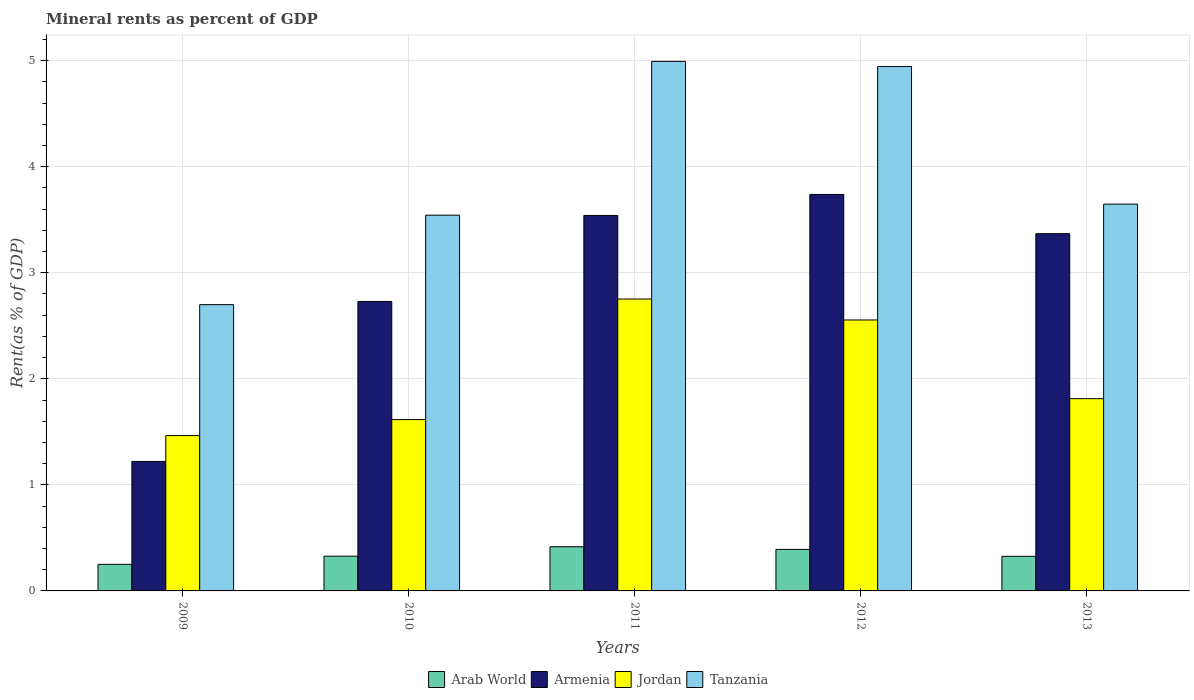How many different coloured bars are there?
Ensure brevity in your answer.  4. How many groups of bars are there?
Your answer should be very brief. 5. Are the number of bars per tick equal to the number of legend labels?
Make the answer very short. Yes. How many bars are there on the 5th tick from the right?
Your answer should be compact. 4. In how many cases, is the number of bars for a given year not equal to the number of legend labels?
Your answer should be very brief. 0. What is the mineral rent in Armenia in 2009?
Provide a short and direct response. 1.22. Across all years, what is the maximum mineral rent in Jordan?
Provide a short and direct response. 2.75. Across all years, what is the minimum mineral rent in Arab World?
Your answer should be very brief. 0.25. In which year was the mineral rent in Tanzania maximum?
Your answer should be very brief. 2011. In which year was the mineral rent in Jordan minimum?
Provide a short and direct response. 2009. What is the total mineral rent in Armenia in the graph?
Ensure brevity in your answer.  14.6. What is the difference between the mineral rent in Arab World in 2011 and that in 2012?
Offer a terse response. 0.03. What is the difference between the mineral rent in Armenia in 2010 and the mineral rent in Jordan in 2013?
Offer a terse response. 0.92. What is the average mineral rent in Jordan per year?
Ensure brevity in your answer.  2.04. In the year 2010, what is the difference between the mineral rent in Jordan and mineral rent in Arab World?
Keep it short and to the point. 1.29. What is the ratio of the mineral rent in Tanzania in 2009 to that in 2013?
Provide a short and direct response. 0.74. Is the mineral rent in Jordan in 2009 less than that in 2010?
Make the answer very short. Yes. What is the difference between the highest and the second highest mineral rent in Armenia?
Ensure brevity in your answer.  0.2. What is the difference between the highest and the lowest mineral rent in Armenia?
Offer a terse response. 2.52. Is the sum of the mineral rent in Jordan in 2012 and 2013 greater than the maximum mineral rent in Armenia across all years?
Provide a short and direct response. Yes. Is it the case that in every year, the sum of the mineral rent in Arab World and mineral rent in Armenia is greater than the sum of mineral rent in Jordan and mineral rent in Tanzania?
Offer a terse response. Yes. What does the 4th bar from the left in 2013 represents?
Your answer should be very brief. Tanzania. What does the 1st bar from the right in 2009 represents?
Ensure brevity in your answer.  Tanzania. Are all the bars in the graph horizontal?
Offer a very short reply. No. Are the values on the major ticks of Y-axis written in scientific E-notation?
Give a very brief answer. No. Does the graph contain any zero values?
Your answer should be compact. No. Where does the legend appear in the graph?
Provide a succinct answer. Bottom center. How many legend labels are there?
Give a very brief answer. 4. How are the legend labels stacked?
Your response must be concise. Horizontal. What is the title of the graph?
Offer a very short reply. Mineral rents as percent of GDP. Does "Chad" appear as one of the legend labels in the graph?
Give a very brief answer. No. What is the label or title of the Y-axis?
Make the answer very short. Rent(as % of GDP). What is the Rent(as % of GDP) of Arab World in 2009?
Ensure brevity in your answer.  0.25. What is the Rent(as % of GDP) of Armenia in 2009?
Provide a short and direct response. 1.22. What is the Rent(as % of GDP) in Jordan in 2009?
Provide a succinct answer. 1.46. What is the Rent(as % of GDP) in Tanzania in 2009?
Make the answer very short. 2.7. What is the Rent(as % of GDP) in Arab World in 2010?
Your answer should be compact. 0.33. What is the Rent(as % of GDP) in Armenia in 2010?
Offer a terse response. 2.73. What is the Rent(as % of GDP) of Jordan in 2010?
Ensure brevity in your answer.  1.62. What is the Rent(as % of GDP) in Tanzania in 2010?
Make the answer very short. 3.54. What is the Rent(as % of GDP) in Arab World in 2011?
Your response must be concise. 0.42. What is the Rent(as % of GDP) of Armenia in 2011?
Make the answer very short. 3.54. What is the Rent(as % of GDP) in Jordan in 2011?
Offer a very short reply. 2.75. What is the Rent(as % of GDP) of Tanzania in 2011?
Provide a succinct answer. 4.99. What is the Rent(as % of GDP) in Arab World in 2012?
Your answer should be very brief. 0.39. What is the Rent(as % of GDP) of Armenia in 2012?
Give a very brief answer. 3.74. What is the Rent(as % of GDP) in Jordan in 2012?
Offer a terse response. 2.55. What is the Rent(as % of GDP) of Tanzania in 2012?
Offer a terse response. 4.94. What is the Rent(as % of GDP) in Arab World in 2013?
Provide a short and direct response. 0.33. What is the Rent(as % of GDP) in Armenia in 2013?
Your response must be concise. 3.37. What is the Rent(as % of GDP) of Jordan in 2013?
Make the answer very short. 1.81. What is the Rent(as % of GDP) in Tanzania in 2013?
Your answer should be very brief. 3.65. Across all years, what is the maximum Rent(as % of GDP) in Arab World?
Offer a terse response. 0.42. Across all years, what is the maximum Rent(as % of GDP) in Armenia?
Provide a succinct answer. 3.74. Across all years, what is the maximum Rent(as % of GDP) in Jordan?
Offer a very short reply. 2.75. Across all years, what is the maximum Rent(as % of GDP) in Tanzania?
Provide a succinct answer. 4.99. Across all years, what is the minimum Rent(as % of GDP) in Arab World?
Keep it short and to the point. 0.25. Across all years, what is the minimum Rent(as % of GDP) in Armenia?
Ensure brevity in your answer.  1.22. Across all years, what is the minimum Rent(as % of GDP) of Jordan?
Offer a very short reply. 1.46. Across all years, what is the minimum Rent(as % of GDP) in Tanzania?
Ensure brevity in your answer.  2.7. What is the total Rent(as % of GDP) of Arab World in the graph?
Offer a terse response. 1.71. What is the total Rent(as % of GDP) of Armenia in the graph?
Offer a terse response. 14.6. What is the total Rent(as % of GDP) in Jordan in the graph?
Offer a very short reply. 10.2. What is the total Rent(as % of GDP) of Tanzania in the graph?
Provide a short and direct response. 19.83. What is the difference between the Rent(as % of GDP) in Arab World in 2009 and that in 2010?
Provide a succinct answer. -0.08. What is the difference between the Rent(as % of GDP) in Armenia in 2009 and that in 2010?
Your answer should be compact. -1.51. What is the difference between the Rent(as % of GDP) in Jordan in 2009 and that in 2010?
Ensure brevity in your answer.  -0.15. What is the difference between the Rent(as % of GDP) of Tanzania in 2009 and that in 2010?
Your response must be concise. -0.84. What is the difference between the Rent(as % of GDP) in Arab World in 2009 and that in 2011?
Keep it short and to the point. -0.17. What is the difference between the Rent(as % of GDP) in Armenia in 2009 and that in 2011?
Provide a short and direct response. -2.32. What is the difference between the Rent(as % of GDP) in Jordan in 2009 and that in 2011?
Offer a very short reply. -1.29. What is the difference between the Rent(as % of GDP) in Tanzania in 2009 and that in 2011?
Provide a succinct answer. -2.29. What is the difference between the Rent(as % of GDP) in Arab World in 2009 and that in 2012?
Give a very brief answer. -0.14. What is the difference between the Rent(as % of GDP) in Armenia in 2009 and that in 2012?
Your answer should be very brief. -2.52. What is the difference between the Rent(as % of GDP) of Jordan in 2009 and that in 2012?
Give a very brief answer. -1.09. What is the difference between the Rent(as % of GDP) of Tanzania in 2009 and that in 2012?
Give a very brief answer. -2.25. What is the difference between the Rent(as % of GDP) of Arab World in 2009 and that in 2013?
Provide a succinct answer. -0.08. What is the difference between the Rent(as % of GDP) in Armenia in 2009 and that in 2013?
Offer a terse response. -2.15. What is the difference between the Rent(as % of GDP) of Jordan in 2009 and that in 2013?
Ensure brevity in your answer.  -0.35. What is the difference between the Rent(as % of GDP) in Tanzania in 2009 and that in 2013?
Give a very brief answer. -0.95. What is the difference between the Rent(as % of GDP) in Arab World in 2010 and that in 2011?
Your answer should be very brief. -0.09. What is the difference between the Rent(as % of GDP) of Armenia in 2010 and that in 2011?
Your answer should be compact. -0.81. What is the difference between the Rent(as % of GDP) in Jordan in 2010 and that in 2011?
Give a very brief answer. -1.14. What is the difference between the Rent(as % of GDP) in Tanzania in 2010 and that in 2011?
Your response must be concise. -1.45. What is the difference between the Rent(as % of GDP) of Arab World in 2010 and that in 2012?
Provide a short and direct response. -0.06. What is the difference between the Rent(as % of GDP) in Armenia in 2010 and that in 2012?
Offer a very short reply. -1.01. What is the difference between the Rent(as % of GDP) of Jordan in 2010 and that in 2012?
Offer a terse response. -0.94. What is the difference between the Rent(as % of GDP) in Tanzania in 2010 and that in 2012?
Your answer should be very brief. -1.4. What is the difference between the Rent(as % of GDP) of Arab World in 2010 and that in 2013?
Make the answer very short. 0. What is the difference between the Rent(as % of GDP) in Armenia in 2010 and that in 2013?
Ensure brevity in your answer.  -0.64. What is the difference between the Rent(as % of GDP) of Jordan in 2010 and that in 2013?
Your response must be concise. -0.2. What is the difference between the Rent(as % of GDP) in Tanzania in 2010 and that in 2013?
Your answer should be very brief. -0.1. What is the difference between the Rent(as % of GDP) of Arab World in 2011 and that in 2012?
Offer a very short reply. 0.03. What is the difference between the Rent(as % of GDP) of Armenia in 2011 and that in 2012?
Keep it short and to the point. -0.2. What is the difference between the Rent(as % of GDP) of Jordan in 2011 and that in 2012?
Give a very brief answer. 0.2. What is the difference between the Rent(as % of GDP) in Tanzania in 2011 and that in 2012?
Make the answer very short. 0.05. What is the difference between the Rent(as % of GDP) in Arab World in 2011 and that in 2013?
Your answer should be very brief. 0.09. What is the difference between the Rent(as % of GDP) of Armenia in 2011 and that in 2013?
Keep it short and to the point. 0.17. What is the difference between the Rent(as % of GDP) of Jordan in 2011 and that in 2013?
Provide a succinct answer. 0.94. What is the difference between the Rent(as % of GDP) in Tanzania in 2011 and that in 2013?
Your answer should be compact. 1.35. What is the difference between the Rent(as % of GDP) of Arab World in 2012 and that in 2013?
Offer a very short reply. 0.07. What is the difference between the Rent(as % of GDP) of Armenia in 2012 and that in 2013?
Ensure brevity in your answer.  0.37. What is the difference between the Rent(as % of GDP) of Jordan in 2012 and that in 2013?
Offer a terse response. 0.74. What is the difference between the Rent(as % of GDP) in Tanzania in 2012 and that in 2013?
Offer a terse response. 1.3. What is the difference between the Rent(as % of GDP) of Arab World in 2009 and the Rent(as % of GDP) of Armenia in 2010?
Provide a short and direct response. -2.48. What is the difference between the Rent(as % of GDP) of Arab World in 2009 and the Rent(as % of GDP) of Jordan in 2010?
Provide a short and direct response. -1.36. What is the difference between the Rent(as % of GDP) of Arab World in 2009 and the Rent(as % of GDP) of Tanzania in 2010?
Offer a very short reply. -3.29. What is the difference between the Rent(as % of GDP) in Armenia in 2009 and the Rent(as % of GDP) in Jordan in 2010?
Give a very brief answer. -0.39. What is the difference between the Rent(as % of GDP) of Armenia in 2009 and the Rent(as % of GDP) of Tanzania in 2010?
Your answer should be compact. -2.32. What is the difference between the Rent(as % of GDP) of Jordan in 2009 and the Rent(as % of GDP) of Tanzania in 2010?
Offer a terse response. -2.08. What is the difference between the Rent(as % of GDP) of Arab World in 2009 and the Rent(as % of GDP) of Armenia in 2011?
Provide a succinct answer. -3.29. What is the difference between the Rent(as % of GDP) of Arab World in 2009 and the Rent(as % of GDP) of Jordan in 2011?
Your answer should be very brief. -2.5. What is the difference between the Rent(as % of GDP) of Arab World in 2009 and the Rent(as % of GDP) of Tanzania in 2011?
Provide a short and direct response. -4.74. What is the difference between the Rent(as % of GDP) in Armenia in 2009 and the Rent(as % of GDP) in Jordan in 2011?
Give a very brief answer. -1.53. What is the difference between the Rent(as % of GDP) in Armenia in 2009 and the Rent(as % of GDP) in Tanzania in 2011?
Offer a very short reply. -3.77. What is the difference between the Rent(as % of GDP) of Jordan in 2009 and the Rent(as % of GDP) of Tanzania in 2011?
Ensure brevity in your answer.  -3.53. What is the difference between the Rent(as % of GDP) of Arab World in 2009 and the Rent(as % of GDP) of Armenia in 2012?
Give a very brief answer. -3.49. What is the difference between the Rent(as % of GDP) in Arab World in 2009 and the Rent(as % of GDP) in Jordan in 2012?
Offer a terse response. -2.3. What is the difference between the Rent(as % of GDP) in Arab World in 2009 and the Rent(as % of GDP) in Tanzania in 2012?
Provide a short and direct response. -4.69. What is the difference between the Rent(as % of GDP) in Armenia in 2009 and the Rent(as % of GDP) in Jordan in 2012?
Keep it short and to the point. -1.33. What is the difference between the Rent(as % of GDP) of Armenia in 2009 and the Rent(as % of GDP) of Tanzania in 2012?
Offer a terse response. -3.72. What is the difference between the Rent(as % of GDP) of Jordan in 2009 and the Rent(as % of GDP) of Tanzania in 2012?
Your response must be concise. -3.48. What is the difference between the Rent(as % of GDP) of Arab World in 2009 and the Rent(as % of GDP) of Armenia in 2013?
Keep it short and to the point. -3.12. What is the difference between the Rent(as % of GDP) in Arab World in 2009 and the Rent(as % of GDP) in Jordan in 2013?
Give a very brief answer. -1.56. What is the difference between the Rent(as % of GDP) of Arab World in 2009 and the Rent(as % of GDP) of Tanzania in 2013?
Your answer should be very brief. -3.4. What is the difference between the Rent(as % of GDP) of Armenia in 2009 and the Rent(as % of GDP) of Jordan in 2013?
Give a very brief answer. -0.59. What is the difference between the Rent(as % of GDP) of Armenia in 2009 and the Rent(as % of GDP) of Tanzania in 2013?
Ensure brevity in your answer.  -2.43. What is the difference between the Rent(as % of GDP) in Jordan in 2009 and the Rent(as % of GDP) in Tanzania in 2013?
Provide a short and direct response. -2.18. What is the difference between the Rent(as % of GDP) of Arab World in 2010 and the Rent(as % of GDP) of Armenia in 2011?
Make the answer very short. -3.21. What is the difference between the Rent(as % of GDP) in Arab World in 2010 and the Rent(as % of GDP) in Jordan in 2011?
Give a very brief answer. -2.42. What is the difference between the Rent(as % of GDP) in Arab World in 2010 and the Rent(as % of GDP) in Tanzania in 2011?
Your answer should be very brief. -4.67. What is the difference between the Rent(as % of GDP) in Armenia in 2010 and the Rent(as % of GDP) in Jordan in 2011?
Offer a very short reply. -0.02. What is the difference between the Rent(as % of GDP) in Armenia in 2010 and the Rent(as % of GDP) in Tanzania in 2011?
Your answer should be compact. -2.26. What is the difference between the Rent(as % of GDP) in Jordan in 2010 and the Rent(as % of GDP) in Tanzania in 2011?
Provide a succinct answer. -3.38. What is the difference between the Rent(as % of GDP) in Arab World in 2010 and the Rent(as % of GDP) in Armenia in 2012?
Provide a succinct answer. -3.41. What is the difference between the Rent(as % of GDP) of Arab World in 2010 and the Rent(as % of GDP) of Jordan in 2012?
Offer a terse response. -2.23. What is the difference between the Rent(as % of GDP) of Arab World in 2010 and the Rent(as % of GDP) of Tanzania in 2012?
Provide a succinct answer. -4.62. What is the difference between the Rent(as % of GDP) of Armenia in 2010 and the Rent(as % of GDP) of Jordan in 2012?
Your answer should be very brief. 0.17. What is the difference between the Rent(as % of GDP) in Armenia in 2010 and the Rent(as % of GDP) in Tanzania in 2012?
Offer a terse response. -2.21. What is the difference between the Rent(as % of GDP) in Jordan in 2010 and the Rent(as % of GDP) in Tanzania in 2012?
Give a very brief answer. -3.33. What is the difference between the Rent(as % of GDP) in Arab World in 2010 and the Rent(as % of GDP) in Armenia in 2013?
Provide a succinct answer. -3.04. What is the difference between the Rent(as % of GDP) of Arab World in 2010 and the Rent(as % of GDP) of Jordan in 2013?
Offer a terse response. -1.49. What is the difference between the Rent(as % of GDP) of Arab World in 2010 and the Rent(as % of GDP) of Tanzania in 2013?
Make the answer very short. -3.32. What is the difference between the Rent(as % of GDP) of Armenia in 2010 and the Rent(as % of GDP) of Jordan in 2013?
Offer a terse response. 0.92. What is the difference between the Rent(as % of GDP) of Armenia in 2010 and the Rent(as % of GDP) of Tanzania in 2013?
Keep it short and to the point. -0.92. What is the difference between the Rent(as % of GDP) in Jordan in 2010 and the Rent(as % of GDP) in Tanzania in 2013?
Ensure brevity in your answer.  -2.03. What is the difference between the Rent(as % of GDP) in Arab World in 2011 and the Rent(as % of GDP) in Armenia in 2012?
Provide a short and direct response. -3.32. What is the difference between the Rent(as % of GDP) in Arab World in 2011 and the Rent(as % of GDP) in Jordan in 2012?
Offer a terse response. -2.14. What is the difference between the Rent(as % of GDP) in Arab World in 2011 and the Rent(as % of GDP) in Tanzania in 2012?
Give a very brief answer. -4.53. What is the difference between the Rent(as % of GDP) of Armenia in 2011 and the Rent(as % of GDP) of Jordan in 2012?
Your answer should be compact. 0.99. What is the difference between the Rent(as % of GDP) in Armenia in 2011 and the Rent(as % of GDP) in Tanzania in 2012?
Keep it short and to the point. -1.4. What is the difference between the Rent(as % of GDP) of Jordan in 2011 and the Rent(as % of GDP) of Tanzania in 2012?
Offer a very short reply. -2.19. What is the difference between the Rent(as % of GDP) in Arab World in 2011 and the Rent(as % of GDP) in Armenia in 2013?
Provide a succinct answer. -2.95. What is the difference between the Rent(as % of GDP) in Arab World in 2011 and the Rent(as % of GDP) in Jordan in 2013?
Give a very brief answer. -1.4. What is the difference between the Rent(as % of GDP) of Arab World in 2011 and the Rent(as % of GDP) of Tanzania in 2013?
Provide a succinct answer. -3.23. What is the difference between the Rent(as % of GDP) in Armenia in 2011 and the Rent(as % of GDP) in Jordan in 2013?
Make the answer very short. 1.73. What is the difference between the Rent(as % of GDP) in Armenia in 2011 and the Rent(as % of GDP) in Tanzania in 2013?
Offer a very short reply. -0.11. What is the difference between the Rent(as % of GDP) in Jordan in 2011 and the Rent(as % of GDP) in Tanzania in 2013?
Provide a short and direct response. -0.89. What is the difference between the Rent(as % of GDP) in Arab World in 2012 and the Rent(as % of GDP) in Armenia in 2013?
Your response must be concise. -2.98. What is the difference between the Rent(as % of GDP) in Arab World in 2012 and the Rent(as % of GDP) in Jordan in 2013?
Offer a very short reply. -1.42. What is the difference between the Rent(as % of GDP) of Arab World in 2012 and the Rent(as % of GDP) of Tanzania in 2013?
Give a very brief answer. -3.26. What is the difference between the Rent(as % of GDP) in Armenia in 2012 and the Rent(as % of GDP) in Jordan in 2013?
Keep it short and to the point. 1.93. What is the difference between the Rent(as % of GDP) of Armenia in 2012 and the Rent(as % of GDP) of Tanzania in 2013?
Ensure brevity in your answer.  0.09. What is the difference between the Rent(as % of GDP) of Jordan in 2012 and the Rent(as % of GDP) of Tanzania in 2013?
Your answer should be very brief. -1.09. What is the average Rent(as % of GDP) of Arab World per year?
Provide a succinct answer. 0.34. What is the average Rent(as % of GDP) in Armenia per year?
Your answer should be very brief. 2.92. What is the average Rent(as % of GDP) in Jordan per year?
Offer a very short reply. 2.04. What is the average Rent(as % of GDP) of Tanzania per year?
Your response must be concise. 3.97. In the year 2009, what is the difference between the Rent(as % of GDP) of Arab World and Rent(as % of GDP) of Armenia?
Offer a very short reply. -0.97. In the year 2009, what is the difference between the Rent(as % of GDP) of Arab World and Rent(as % of GDP) of Jordan?
Provide a short and direct response. -1.21. In the year 2009, what is the difference between the Rent(as % of GDP) in Arab World and Rent(as % of GDP) in Tanzania?
Keep it short and to the point. -2.45. In the year 2009, what is the difference between the Rent(as % of GDP) in Armenia and Rent(as % of GDP) in Jordan?
Provide a succinct answer. -0.24. In the year 2009, what is the difference between the Rent(as % of GDP) in Armenia and Rent(as % of GDP) in Tanzania?
Offer a terse response. -1.48. In the year 2009, what is the difference between the Rent(as % of GDP) in Jordan and Rent(as % of GDP) in Tanzania?
Make the answer very short. -1.23. In the year 2010, what is the difference between the Rent(as % of GDP) in Arab World and Rent(as % of GDP) in Armenia?
Provide a succinct answer. -2.4. In the year 2010, what is the difference between the Rent(as % of GDP) in Arab World and Rent(as % of GDP) in Jordan?
Give a very brief answer. -1.29. In the year 2010, what is the difference between the Rent(as % of GDP) of Arab World and Rent(as % of GDP) of Tanzania?
Offer a terse response. -3.21. In the year 2010, what is the difference between the Rent(as % of GDP) in Armenia and Rent(as % of GDP) in Jordan?
Keep it short and to the point. 1.11. In the year 2010, what is the difference between the Rent(as % of GDP) in Armenia and Rent(as % of GDP) in Tanzania?
Give a very brief answer. -0.81. In the year 2010, what is the difference between the Rent(as % of GDP) in Jordan and Rent(as % of GDP) in Tanzania?
Your answer should be very brief. -1.93. In the year 2011, what is the difference between the Rent(as % of GDP) of Arab World and Rent(as % of GDP) of Armenia?
Provide a succinct answer. -3.12. In the year 2011, what is the difference between the Rent(as % of GDP) of Arab World and Rent(as % of GDP) of Jordan?
Give a very brief answer. -2.34. In the year 2011, what is the difference between the Rent(as % of GDP) of Arab World and Rent(as % of GDP) of Tanzania?
Offer a very short reply. -4.58. In the year 2011, what is the difference between the Rent(as % of GDP) in Armenia and Rent(as % of GDP) in Jordan?
Your answer should be compact. 0.79. In the year 2011, what is the difference between the Rent(as % of GDP) in Armenia and Rent(as % of GDP) in Tanzania?
Keep it short and to the point. -1.45. In the year 2011, what is the difference between the Rent(as % of GDP) in Jordan and Rent(as % of GDP) in Tanzania?
Make the answer very short. -2.24. In the year 2012, what is the difference between the Rent(as % of GDP) of Arab World and Rent(as % of GDP) of Armenia?
Provide a succinct answer. -3.35. In the year 2012, what is the difference between the Rent(as % of GDP) in Arab World and Rent(as % of GDP) in Jordan?
Provide a short and direct response. -2.16. In the year 2012, what is the difference between the Rent(as % of GDP) of Arab World and Rent(as % of GDP) of Tanzania?
Make the answer very short. -4.55. In the year 2012, what is the difference between the Rent(as % of GDP) in Armenia and Rent(as % of GDP) in Jordan?
Give a very brief answer. 1.18. In the year 2012, what is the difference between the Rent(as % of GDP) of Armenia and Rent(as % of GDP) of Tanzania?
Make the answer very short. -1.21. In the year 2012, what is the difference between the Rent(as % of GDP) of Jordan and Rent(as % of GDP) of Tanzania?
Your response must be concise. -2.39. In the year 2013, what is the difference between the Rent(as % of GDP) in Arab World and Rent(as % of GDP) in Armenia?
Your response must be concise. -3.04. In the year 2013, what is the difference between the Rent(as % of GDP) of Arab World and Rent(as % of GDP) of Jordan?
Offer a very short reply. -1.49. In the year 2013, what is the difference between the Rent(as % of GDP) in Arab World and Rent(as % of GDP) in Tanzania?
Ensure brevity in your answer.  -3.32. In the year 2013, what is the difference between the Rent(as % of GDP) in Armenia and Rent(as % of GDP) in Jordan?
Provide a short and direct response. 1.56. In the year 2013, what is the difference between the Rent(as % of GDP) of Armenia and Rent(as % of GDP) of Tanzania?
Ensure brevity in your answer.  -0.28. In the year 2013, what is the difference between the Rent(as % of GDP) of Jordan and Rent(as % of GDP) of Tanzania?
Provide a succinct answer. -1.83. What is the ratio of the Rent(as % of GDP) in Arab World in 2009 to that in 2010?
Offer a very short reply. 0.76. What is the ratio of the Rent(as % of GDP) in Armenia in 2009 to that in 2010?
Give a very brief answer. 0.45. What is the ratio of the Rent(as % of GDP) of Jordan in 2009 to that in 2010?
Keep it short and to the point. 0.91. What is the ratio of the Rent(as % of GDP) in Tanzania in 2009 to that in 2010?
Your answer should be compact. 0.76. What is the ratio of the Rent(as % of GDP) of Arab World in 2009 to that in 2011?
Provide a succinct answer. 0.6. What is the ratio of the Rent(as % of GDP) in Armenia in 2009 to that in 2011?
Keep it short and to the point. 0.34. What is the ratio of the Rent(as % of GDP) in Jordan in 2009 to that in 2011?
Offer a terse response. 0.53. What is the ratio of the Rent(as % of GDP) of Tanzania in 2009 to that in 2011?
Provide a short and direct response. 0.54. What is the ratio of the Rent(as % of GDP) of Arab World in 2009 to that in 2012?
Give a very brief answer. 0.64. What is the ratio of the Rent(as % of GDP) in Armenia in 2009 to that in 2012?
Provide a short and direct response. 0.33. What is the ratio of the Rent(as % of GDP) in Jordan in 2009 to that in 2012?
Keep it short and to the point. 0.57. What is the ratio of the Rent(as % of GDP) of Tanzania in 2009 to that in 2012?
Give a very brief answer. 0.55. What is the ratio of the Rent(as % of GDP) in Arab World in 2009 to that in 2013?
Give a very brief answer. 0.77. What is the ratio of the Rent(as % of GDP) in Armenia in 2009 to that in 2013?
Keep it short and to the point. 0.36. What is the ratio of the Rent(as % of GDP) in Jordan in 2009 to that in 2013?
Provide a short and direct response. 0.81. What is the ratio of the Rent(as % of GDP) of Tanzania in 2009 to that in 2013?
Provide a succinct answer. 0.74. What is the ratio of the Rent(as % of GDP) of Arab World in 2010 to that in 2011?
Keep it short and to the point. 0.79. What is the ratio of the Rent(as % of GDP) of Armenia in 2010 to that in 2011?
Make the answer very short. 0.77. What is the ratio of the Rent(as % of GDP) of Jordan in 2010 to that in 2011?
Offer a very short reply. 0.59. What is the ratio of the Rent(as % of GDP) of Tanzania in 2010 to that in 2011?
Keep it short and to the point. 0.71. What is the ratio of the Rent(as % of GDP) of Arab World in 2010 to that in 2012?
Make the answer very short. 0.84. What is the ratio of the Rent(as % of GDP) of Armenia in 2010 to that in 2012?
Make the answer very short. 0.73. What is the ratio of the Rent(as % of GDP) in Jordan in 2010 to that in 2012?
Give a very brief answer. 0.63. What is the ratio of the Rent(as % of GDP) of Tanzania in 2010 to that in 2012?
Offer a very short reply. 0.72. What is the ratio of the Rent(as % of GDP) in Arab World in 2010 to that in 2013?
Make the answer very short. 1. What is the ratio of the Rent(as % of GDP) of Armenia in 2010 to that in 2013?
Your response must be concise. 0.81. What is the ratio of the Rent(as % of GDP) of Jordan in 2010 to that in 2013?
Ensure brevity in your answer.  0.89. What is the ratio of the Rent(as % of GDP) in Tanzania in 2010 to that in 2013?
Provide a succinct answer. 0.97. What is the ratio of the Rent(as % of GDP) of Arab World in 2011 to that in 2012?
Offer a very short reply. 1.06. What is the ratio of the Rent(as % of GDP) of Armenia in 2011 to that in 2012?
Your response must be concise. 0.95. What is the ratio of the Rent(as % of GDP) in Jordan in 2011 to that in 2012?
Your answer should be very brief. 1.08. What is the ratio of the Rent(as % of GDP) in Tanzania in 2011 to that in 2012?
Your response must be concise. 1.01. What is the ratio of the Rent(as % of GDP) in Arab World in 2011 to that in 2013?
Ensure brevity in your answer.  1.28. What is the ratio of the Rent(as % of GDP) of Armenia in 2011 to that in 2013?
Provide a succinct answer. 1.05. What is the ratio of the Rent(as % of GDP) in Jordan in 2011 to that in 2013?
Keep it short and to the point. 1.52. What is the ratio of the Rent(as % of GDP) in Tanzania in 2011 to that in 2013?
Provide a succinct answer. 1.37. What is the ratio of the Rent(as % of GDP) of Arab World in 2012 to that in 2013?
Give a very brief answer. 1.2. What is the ratio of the Rent(as % of GDP) in Armenia in 2012 to that in 2013?
Provide a succinct answer. 1.11. What is the ratio of the Rent(as % of GDP) in Jordan in 2012 to that in 2013?
Ensure brevity in your answer.  1.41. What is the ratio of the Rent(as % of GDP) in Tanzania in 2012 to that in 2013?
Provide a succinct answer. 1.36. What is the difference between the highest and the second highest Rent(as % of GDP) in Arab World?
Provide a short and direct response. 0.03. What is the difference between the highest and the second highest Rent(as % of GDP) of Armenia?
Your answer should be very brief. 0.2. What is the difference between the highest and the second highest Rent(as % of GDP) of Jordan?
Offer a very short reply. 0.2. What is the difference between the highest and the second highest Rent(as % of GDP) in Tanzania?
Offer a very short reply. 0.05. What is the difference between the highest and the lowest Rent(as % of GDP) of Arab World?
Offer a terse response. 0.17. What is the difference between the highest and the lowest Rent(as % of GDP) of Armenia?
Offer a terse response. 2.52. What is the difference between the highest and the lowest Rent(as % of GDP) in Jordan?
Provide a succinct answer. 1.29. What is the difference between the highest and the lowest Rent(as % of GDP) of Tanzania?
Keep it short and to the point. 2.29. 